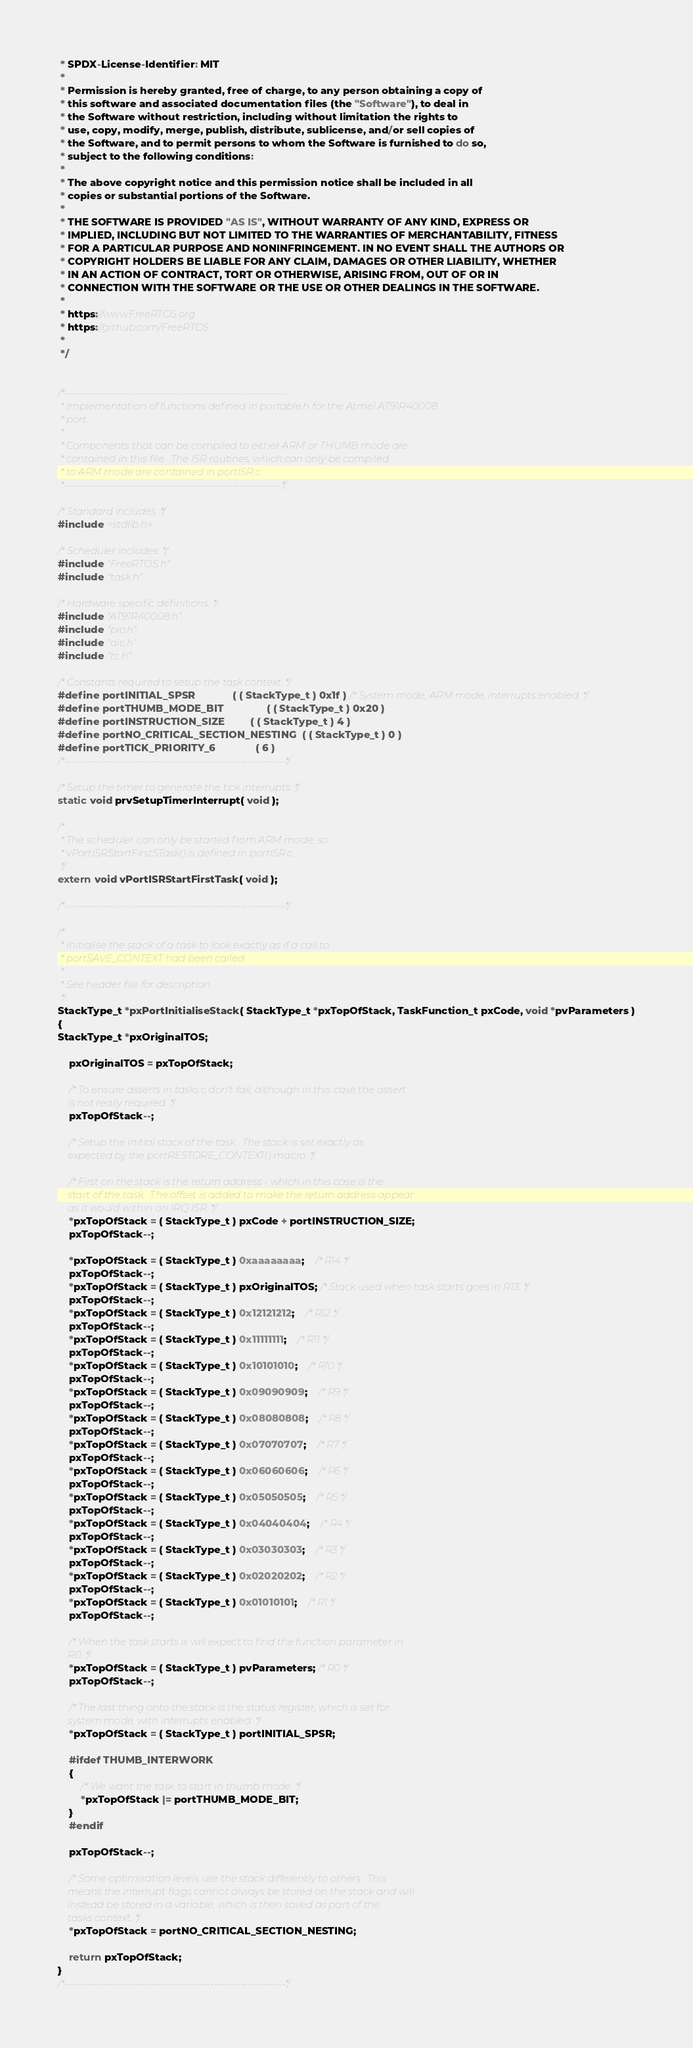<code> <loc_0><loc_0><loc_500><loc_500><_C_> * SPDX-License-Identifier: MIT
 *
 * Permission is hereby granted, free of charge, to any person obtaining a copy of
 * this software and associated documentation files (the "Software"), to deal in
 * the Software without restriction, including without limitation the rights to
 * use, copy, modify, merge, publish, distribute, sublicense, and/or sell copies of
 * the Software, and to permit persons to whom the Software is furnished to do so,
 * subject to the following conditions:
 *
 * The above copyright notice and this permission notice shall be included in all
 * copies or substantial portions of the Software.
 *
 * THE SOFTWARE IS PROVIDED "AS IS", WITHOUT WARRANTY OF ANY KIND, EXPRESS OR
 * IMPLIED, INCLUDING BUT NOT LIMITED TO THE WARRANTIES OF MERCHANTABILITY, FITNESS
 * FOR A PARTICULAR PURPOSE AND NONINFRINGEMENT. IN NO EVENT SHALL THE AUTHORS OR
 * COPYRIGHT HOLDERS BE LIABLE FOR ANY CLAIM, DAMAGES OR OTHER LIABILITY, WHETHER
 * IN AN ACTION OF CONTRACT, TORT OR OTHERWISE, ARISING FROM, OUT OF OR IN
 * CONNECTION WITH THE SOFTWARE OR THE USE OR OTHER DEALINGS IN THE SOFTWARE.
 *
 * https://www.FreeRTOS.org
 * https://github.com/FreeRTOS
 *
 */


/*-----------------------------------------------------------
 * Implementation of functions defined in portable.h for the Atmel AT91R40008
 * port.
 *
 * Components that can be compiled to either ARM or THUMB mode are
 * contained in this file.  The ISR routines, which can only be compiled
 * to ARM mode are contained in portISR.c.
 *----------------------------------------------------------*/

/* Standard includes. */
#include <stdlib.h>

/* Scheduler includes. */
#include "FreeRTOS.h"
#include "task.h"

/* Hardware specific definitions. */
#include "AT91R40008.h"
#include "pio.h"
#include "aic.h"
#include "tc.h"

/* Constants required to setup the task context. */
#define portINITIAL_SPSR				( ( StackType_t ) 0x1f ) /* System mode, ARM mode, interrupts enabled. */
#define portTHUMB_MODE_BIT				( ( StackType_t ) 0x20 )
#define portINSTRUCTION_SIZE			( ( StackType_t ) 4 )
#define portNO_CRITICAL_SECTION_NESTING	( ( StackType_t ) 0 )
#define portTICK_PRIORITY_6				( 6 )
/*-----------------------------------------------------------*/

/* Setup the timer to generate the tick interrupts. */
static void prvSetupTimerInterrupt( void );

/* 
 * The scheduler can only be started from ARM mode, so 
 * vPortISRStartFirstSTask() is defined in portISR.c. 
 */
extern void vPortISRStartFirstTask( void );

/*-----------------------------------------------------------*/

/* 
 * Initialise the stack of a task to look exactly as if a call to 
 * portSAVE_CONTEXT had been called.
 *
 * See header file for description. 
 */
StackType_t *pxPortInitialiseStack( StackType_t *pxTopOfStack, TaskFunction_t pxCode, void *pvParameters )
{
StackType_t *pxOriginalTOS;

	pxOriginalTOS = pxTopOfStack;
	
	/* To ensure asserts in tasks.c don't fail, although in this case the assert
	is not really required. */
	pxTopOfStack--;

	/* Setup the initial stack of the task.  The stack is set exactly as 
	expected by the portRESTORE_CONTEXT() macro. */

	/* First on the stack is the return address - which in this case is the
	start of the task.  The offset is added to make the return address appear
	as it would within an IRQ ISR. */
	*pxTopOfStack = ( StackType_t ) pxCode + portINSTRUCTION_SIZE;		
	pxTopOfStack--;

	*pxTopOfStack = ( StackType_t ) 0xaaaaaaaa;	/* R14 */
	pxTopOfStack--;	
	*pxTopOfStack = ( StackType_t ) pxOriginalTOS; /* Stack used when task starts goes in R13. */
	pxTopOfStack--;
	*pxTopOfStack = ( StackType_t ) 0x12121212;	/* R12 */
	pxTopOfStack--;	
	*pxTopOfStack = ( StackType_t ) 0x11111111;	/* R11 */
	pxTopOfStack--;	
	*pxTopOfStack = ( StackType_t ) 0x10101010;	/* R10 */
	pxTopOfStack--;	
	*pxTopOfStack = ( StackType_t ) 0x09090909;	/* R9 */
	pxTopOfStack--;	
	*pxTopOfStack = ( StackType_t ) 0x08080808;	/* R8 */
	pxTopOfStack--;	
	*pxTopOfStack = ( StackType_t ) 0x07070707;	/* R7 */
	pxTopOfStack--;	
	*pxTopOfStack = ( StackType_t ) 0x06060606;	/* R6 */
	pxTopOfStack--;	
	*pxTopOfStack = ( StackType_t ) 0x05050505;	/* R5 */
	pxTopOfStack--;	
	*pxTopOfStack = ( StackType_t ) 0x04040404;	/* R4 */
	pxTopOfStack--;	
	*pxTopOfStack = ( StackType_t ) 0x03030303;	/* R3 */
	pxTopOfStack--;	
	*pxTopOfStack = ( StackType_t ) 0x02020202;	/* R2 */
	pxTopOfStack--;	
	*pxTopOfStack = ( StackType_t ) 0x01010101;	/* R1 */
	pxTopOfStack--;	

	/* When the task starts is will expect to find the function parameter in
	R0. */
	*pxTopOfStack = ( StackType_t ) pvParameters; /* R0 */
	pxTopOfStack--;

	/* The last thing onto the stack is the status register, which is set for
	system mode, with interrupts enabled. */
	*pxTopOfStack = ( StackType_t ) portINITIAL_SPSR;

	#ifdef THUMB_INTERWORK
	{
		/* We want the task to start in thumb mode. */
		*pxTopOfStack |= portTHUMB_MODE_BIT;
	}
	#endif

	pxTopOfStack--;

	/* Some optimisation levels use the stack differently to others.  This 
	means the interrupt flags cannot always be stored on the stack and will
	instead be stored in a variable, which is then saved as part of the
	tasks context. */
	*pxTopOfStack = portNO_CRITICAL_SECTION_NESTING;

	return pxTopOfStack;
}
/*-----------------------------------------------------------*/
</code> 